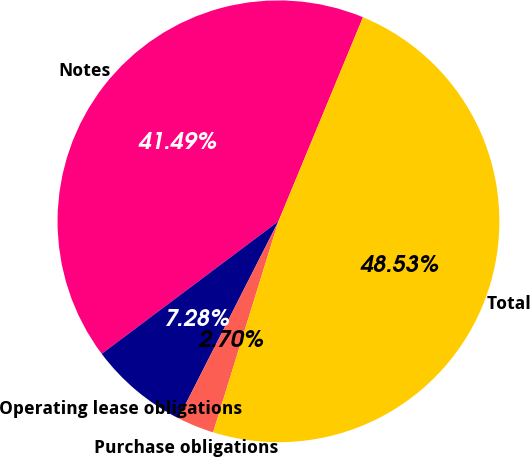<chart> <loc_0><loc_0><loc_500><loc_500><pie_chart><fcel>Notes<fcel>Operating lease obligations<fcel>Purchase obligations<fcel>Total<nl><fcel>41.49%<fcel>7.28%<fcel>2.7%<fcel>48.53%<nl></chart> 